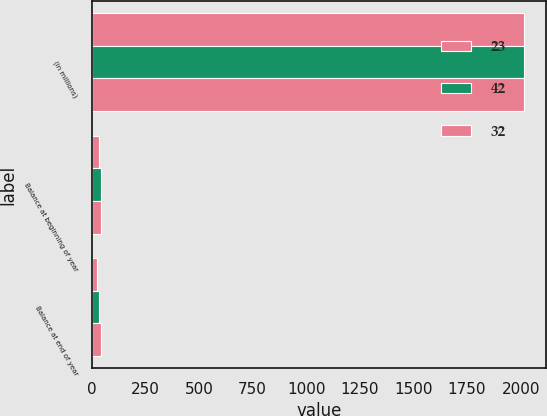Convert chart to OTSL. <chart><loc_0><loc_0><loc_500><loc_500><stacked_bar_chart><ecel><fcel>(in millions)<fcel>Balance at beginning of year<fcel>Balance at end of year<nl><fcel>23<fcel>2017<fcel>32<fcel>23<nl><fcel>42<fcel>2016<fcel>42<fcel>32<nl><fcel>32<fcel>2015<fcel>42<fcel>42<nl></chart> 